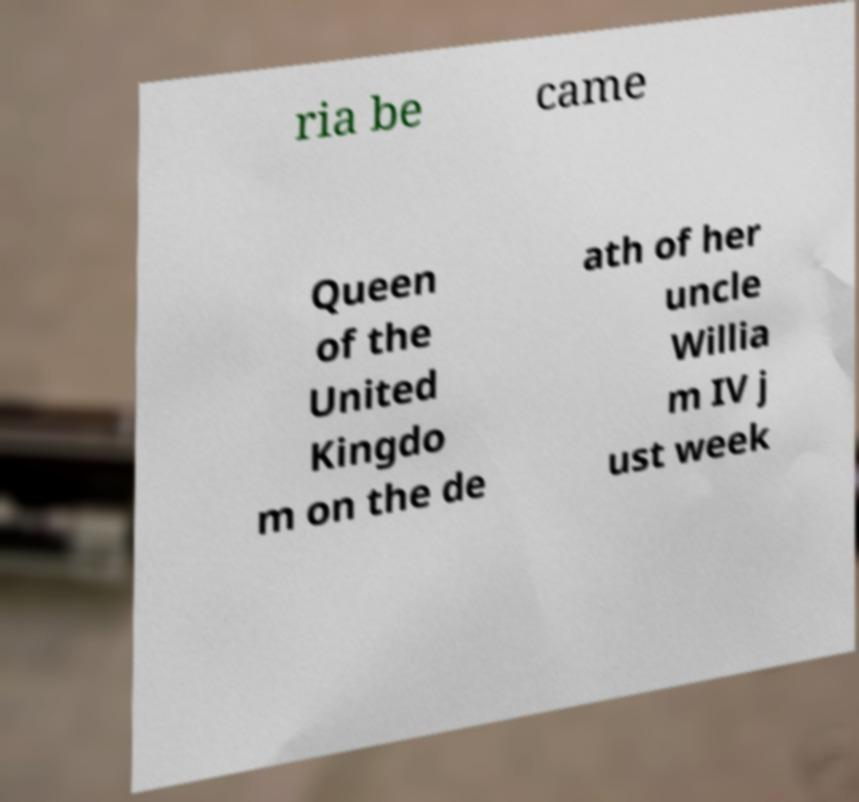Please identify and transcribe the text found in this image. ria be came Queen of the United Kingdo m on the de ath of her uncle Willia m IV j ust week 